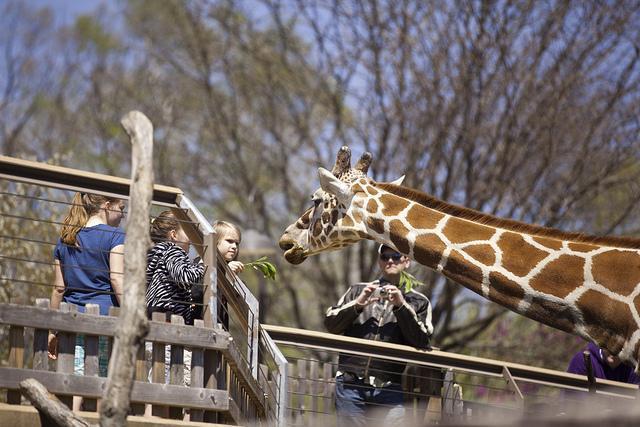How many giraffes are in the picture?
Give a very brief answer. 1. How many people can be seen?
Give a very brief answer. 3. How many orange signs are there?
Give a very brief answer. 0. 